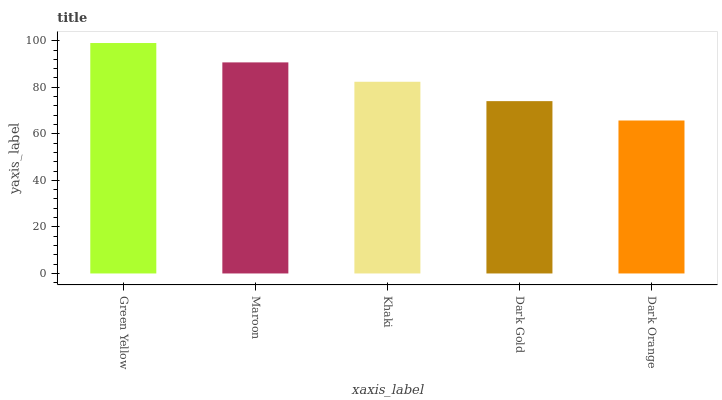Is Maroon the minimum?
Answer yes or no. No. Is Maroon the maximum?
Answer yes or no. No. Is Green Yellow greater than Maroon?
Answer yes or no. Yes. Is Maroon less than Green Yellow?
Answer yes or no. Yes. Is Maroon greater than Green Yellow?
Answer yes or no. No. Is Green Yellow less than Maroon?
Answer yes or no. No. Is Khaki the high median?
Answer yes or no. Yes. Is Khaki the low median?
Answer yes or no. Yes. Is Maroon the high median?
Answer yes or no. No. Is Dark Gold the low median?
Answer yes or no. No. 